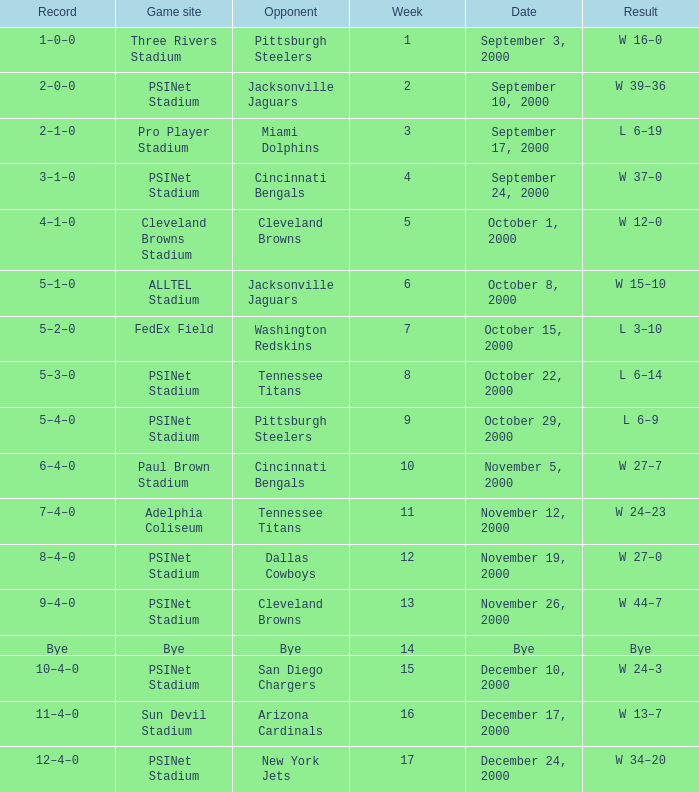What's the result at psinet stadium when the cincinnati bengals are the opponent? W 37–0. 